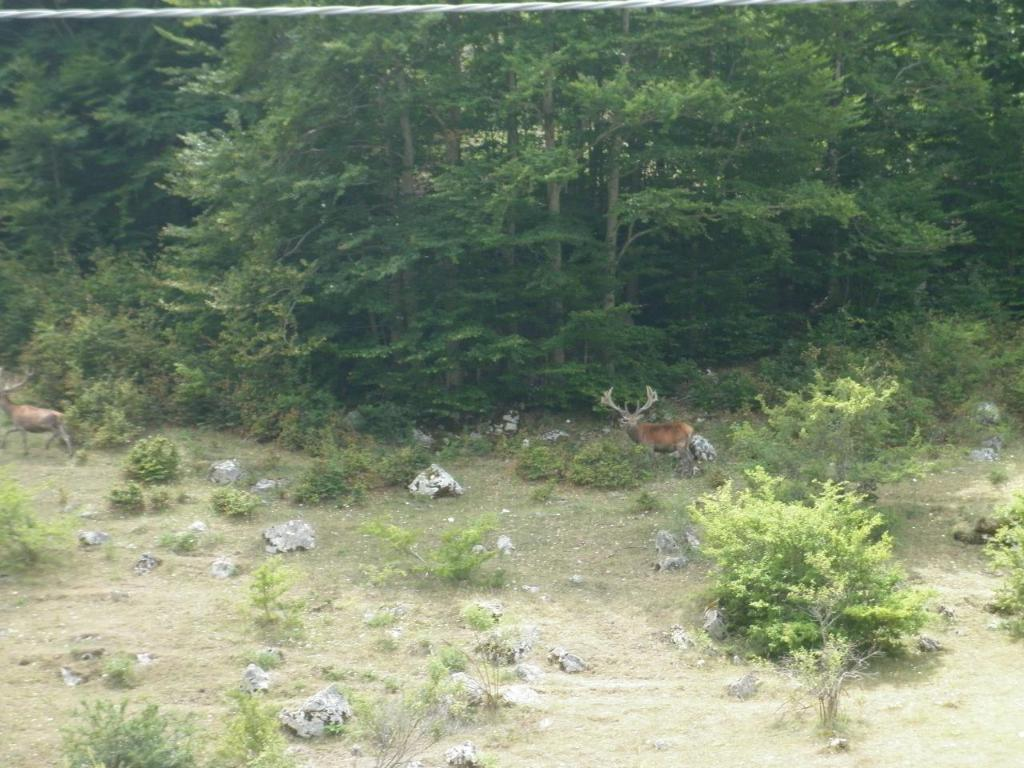How many deer are in the image? There are two deer in the image. What type of terrain are the deer on? The deer are on grassy land. What can be seen in the background of the image? There are trees in the background of the image. What type of vegetation is visible in the image? There is grass and small plants visible in the image. What type of owl can be seen perched on the army's limit in the image? There is no owl, army, or limit present in the image; it features two deer on grassy land with trees in the background. 